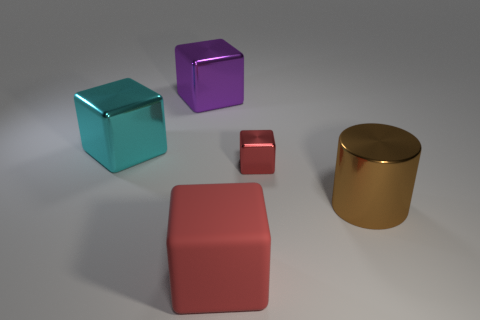Is the number of large metal blocks greater than the number of metallic blocks?
Your response must be concise. No. What number of other things are the same color as the small cube?
Offer a terse response. 1. Is the material of the big cylinder the same as the big thing to the left of the big purple shiny block?
Make the answer very short. Yes. There is a object that is to the right of the red thing behind the big red cube; what number of brown metallic objects are behind it?
Your answer should be very brief. 0. Are there fewer cyan blocks in front of the red rubber object than small metallic things that are left of the big cyan block?
Your response must be concise. No. How many other things are the same material as the tiny object?
Offer a very short reply. 3. What is the material of the brown cylinder that is the same size as the cyan cube?
Your response must be concise. Metal. What number of green things are either big rubber things or tiny objects?
Keep it short and to the point. 0. There is a object that is in front of the red shiny thing and behind the big red cube; what color is it?
Offer a terse response. Brown. Does the block behind the large cyan object have the same material as the thing to the right of the small red cube?
Your answer should be compact. Yes. 